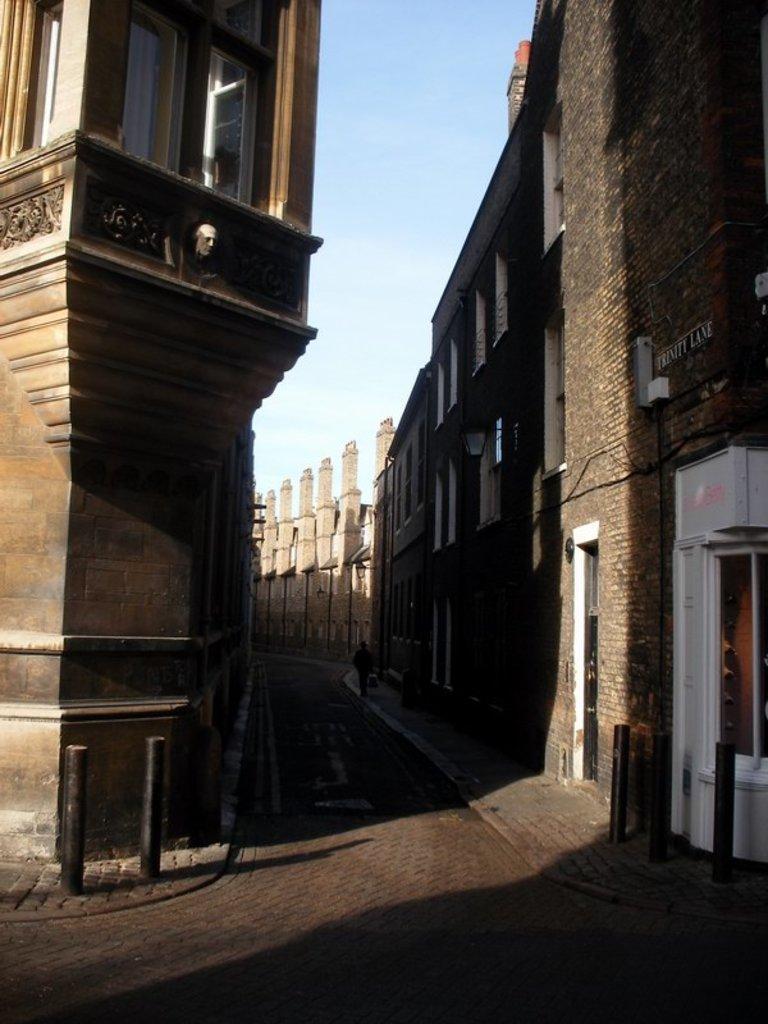Describe this image in one or two sentences. In this picture I can see the road in between the buildings. 